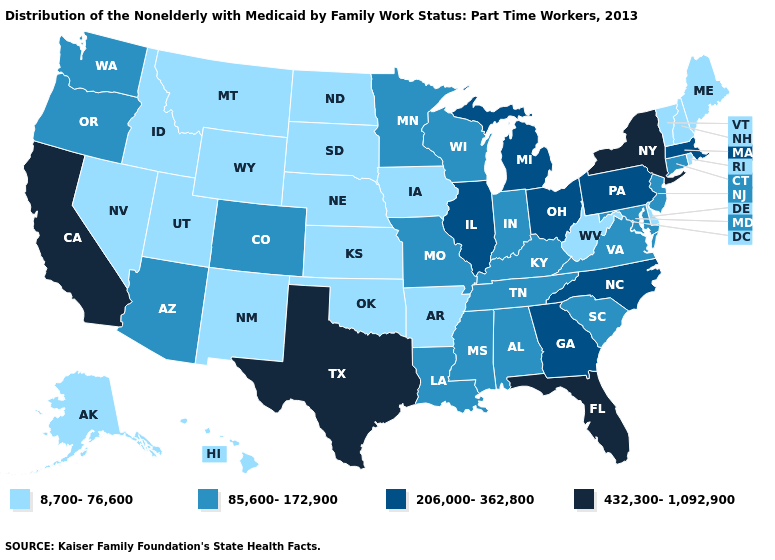Does West Virginia have a lower value than Nevada?
Quick response, please. No. Does Maine have a lower value than Utah?
Short answer required. No. What is the highest value in states that border Vermont?
Quick response, please. 432,300-1,092,900. What is the lowest value in the South?
Concise answer only. 8,700-76,600. Is the legend a continuous bar?
Quick response, please. No. What is the value of Montana?
Keep it brief. 8,700-76,600. Name the states that have a value in the range 8,700-76,600?
Concise answer only. Alaska, Arkansas, Delaware, Hawaii, Idaho, Iowa, Kansas, Maine, Montana, Nebraska, Nevada, New Hampshire, New Mexico, North Dakota, Oklahoma, Rhode Island, South Dakota, Utah, Vermont, West Virginia, Wyoming. Name the states that have a value in the range 8,700-76,600?
Concise answer only. Alaska, Arkansas, Delaware, Hawaii, Idaho, Iowa, Kansas, Maine, Montana, Nebraska, Nevada, New Hampshire, New Mexico, North Dakota, Oklahoma, Rhode Island, South Dakota, Utah, Vermont, West Virginia, Wyoming. Among the states that border Nevada , does California have the lowest value?
Short answer required. No. Does New Jersey have a lower value than New York?
Answer briefly. Yes. Does Idaho have a higher value than Oregon?
Short answer required. No. Does New York have the highest value in the Northeast?
Short answer required. Yes. Does Virginia have a lower value than Ohio?
Quick response, please. Yes. What is the highest value in the USA?
Concise answer only. 432,300-1,092,900. What is the value of Kansas?
Be succinct. 8,700-76,600. 